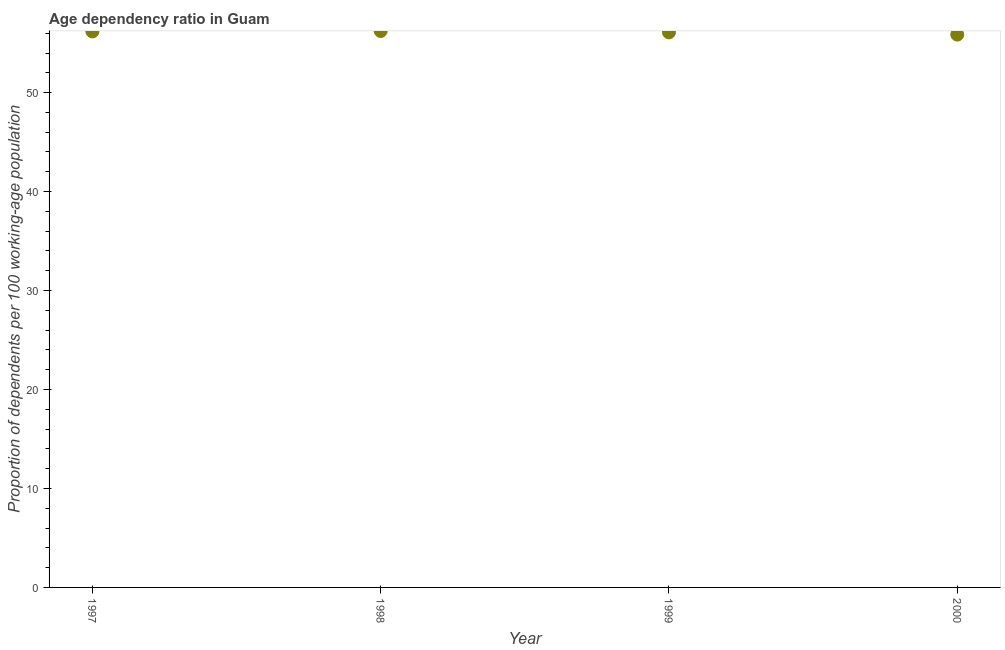What is the age dependency ratio in 1998?
Provide a succinct answer. 56.22. Across all years, what is the maximum age dependency ratio?
Provide a short and direct response. 56.22. Across all years, what is the minimum age dependency ratio?
Make the answer very short. 55.86. In which year was the age dependency ratio maximum?
Ensure brevity in your answer.  1998. In which year was the age dependency ratio minimum?
Your answer should be very brief. 2000. What is the sum of the age dependency ratio?
Your response must be concise. 224.35. What is the difference between the age dependency ratio in 1998 and 2000?
Keep it short and to the point. 0.36. What is the average age dependency ratio per year?
Your answer should be compact. 56.09. What is the median age dependency ratio?
Make the answer very short. 56.13. In how many years, is the age dependency ratio greater than 48 ?
Provide a succinct answer. 4. What is the ratio of the age dependency ratio in 1997 to that in 1999?
Provide a succinct answer. 1. What is the difference between the highest and the second highest age dependency ratio?
Keep it short and to the point. 0.04. Is the sum of the age dependency ratio in 1999 and 2000 greater than the maximum age dependency ratio across all years?
Provide a succinct answer. Yes. What is the difference between the highest and the lowest age dependency ratio?
Give a very brief answer. 0.36. Does the age dependency ratio monotonically increase over the years?
Provide a short and direct response. No. How many dotlines are there?
Offer a very short reply. 1. How many years are there in the graph?
Your answer should be very brief. 4. What is the difference between two consecutive major ticks on the Y-axis?
Keep it short and to the point. 10. Are the values on the major ticks of Y-axis written in scientific E-notation?
Give a very brief answer. No. What is the title of the graph?
Keep it short and to the point. Age dependency ratio in Guam. What is the label or title of the X-axis?
Offer a terse response. Year. What is the label or title of the Y-axis?
Offer a very short reply. Proportion of dependents per 100 working-age population. What is the Proportion of dependents per 100 working-age population in 1997?
Provide a succinct answer. 56.18. What is the Proportion of dependents per 100 working-age population in 1998?
Keep it short and to the point. 56.22. What is the Proportion of dependents per 100 working-age population in 1999?
Make the answer very short. 56.09. What is the Proportion of dependents per 100 working-age population in 2000?
Make the answer very short. 55.86. What is the difference between the Proportion of dependents per 100 working-age population in 1997 and 1998?
Provide a succinct answer. -0.04. What is the difference between the Proportion of dependents per 100 working-age population in 1997 and 1999?
Give a very brief answer. 0.1. What is the difference between the Proportion of dependents per 100 working-age population in 1997 and 2000?
Make the answer very short. 0.32. What is the difference between the Proportion of dependents per 100 working-age population in 1998 and 1999?
Your response must be concise. 0.14. What is the difference between the Proportion of dependents per 100 working-age population in 1998 and 2000?
Your answer should be compact. 0.36. What is the difference between the Proportion of dependents per 100 working-age population in 1999 and 2000?
Make the answer very short. 0.23. What is the ratio of the Proportion of dependents per 100 working-age population in 1997 to that in 1999?
Keep it short and to the point. 1. 